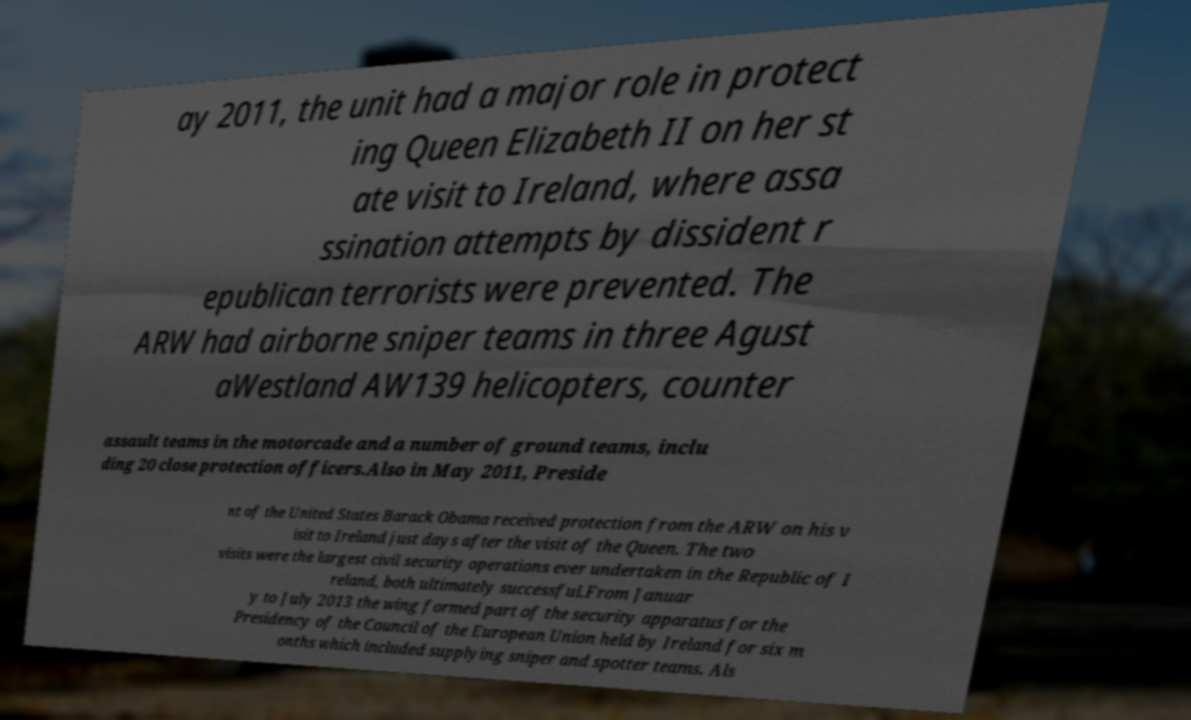I need the written content from this picture converted into text. Can you do that? ay 2011, the unit had a major role in protect ing Queen Elizabeth II on her st ate visit to Ireland, where assa ssination attempts by dissident r epublican terrorists were prevented. The ARW had airborne sniper teams in three Agust aWestland AW139 helicopters, counter assault teams in the motorcade and a number of ground teams, inclu ding 20 close protection officers.Also in May 2011, Preside nt of the United States Barack Obama received protection from the ARW on his v isit to Ireland just days after the visit of the Queen. The two visits were the largest civil security operations ever undertaken in the Republic of I reland, both ultimately successful.From Januar y to July 2013 the wing formed part of the security apparatus for the Presidency of the Council of the European Union held by Ireland for six m onths which included supplying sniper and spotter teams. Als 